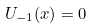Convert formula to latex. <formula><loc_0><loc_0><loc_500><loc_500>U _ { - 1 } ( x ) = 0</formula> 